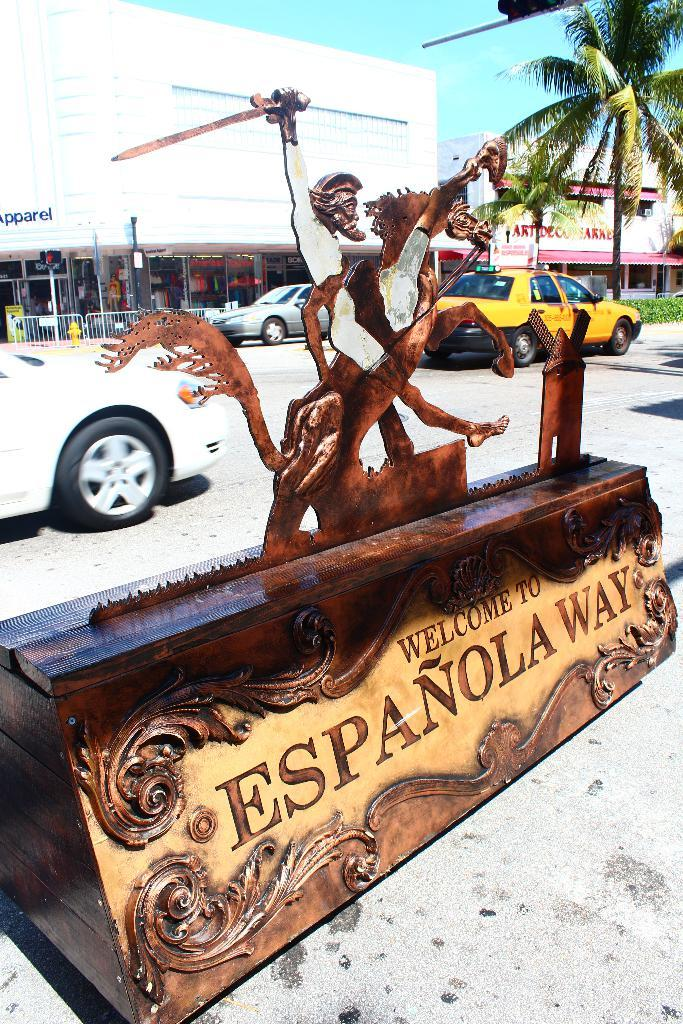<image>
Give a short and clear explanation of the subsequent image. The statues promotes a greeting to Espanola Way. 